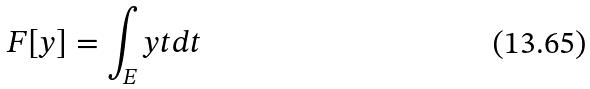Convert formula to latex. <formula><loc_0><loc_0><loc_500><loc_500>F [ y ] = \int _ { E } y t d t</formula> 